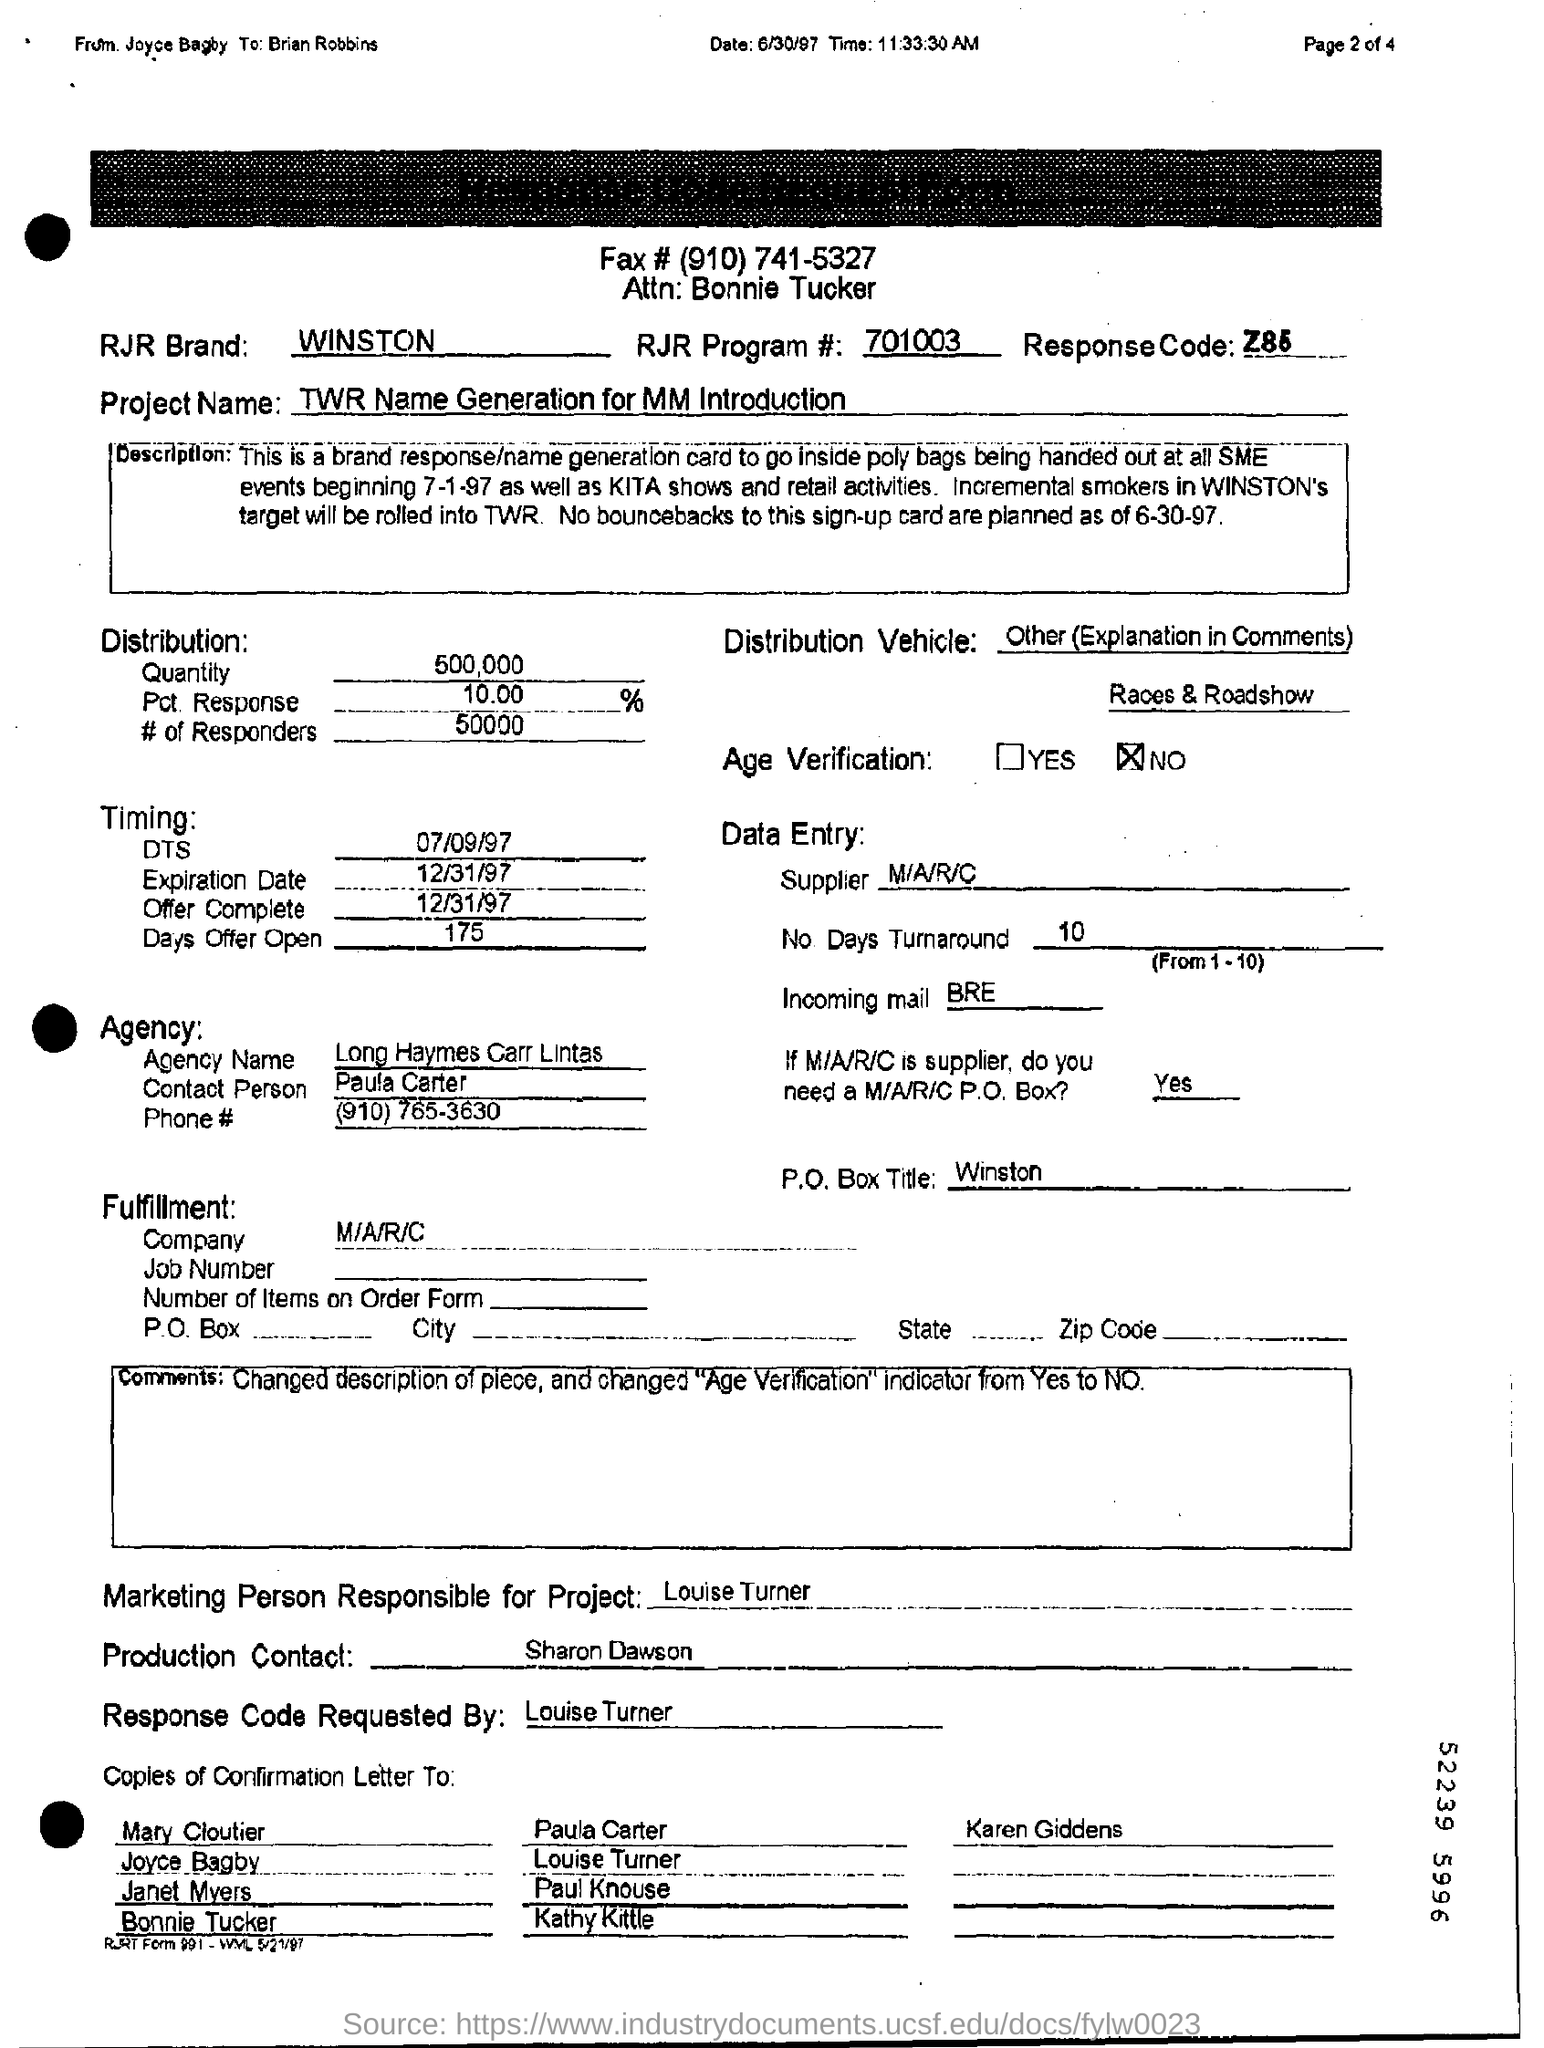Highlight a few significant elements in this photo. Louise Turner is the marketing person responsible for the project. The project is known as TWR Name Generation for MM Introduction. There is no age verification in the provided fax. Long Haymes Carr Lintas is the name of the agency. 